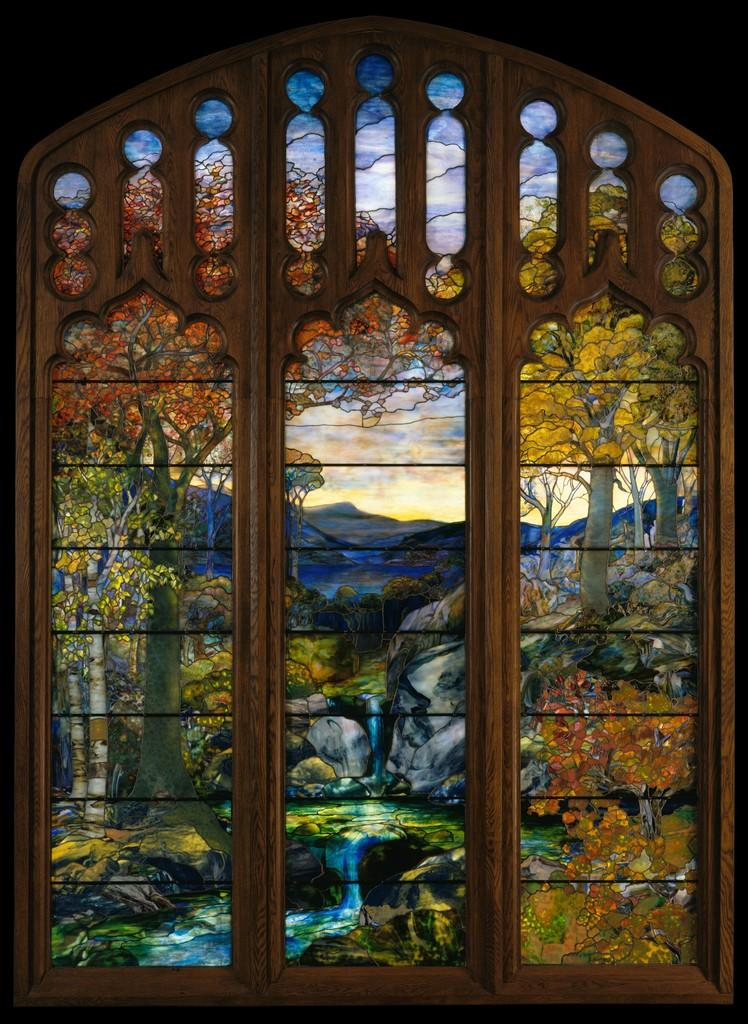What type of opening can be seen in the image? There is a window in the image. What is located near the window? There is a glass visible in the image. What type of natural scenery is visible in the image? Trees are visible in the image. What type of terrain is present in the image? Rocks are present in the image. What is visible above the trees and rocks in the image? The sky is visible in the image. How many bikes are being ridden by the creator in the image? There is no creator or bikes present in the image. What type of worm can be seen crawling on the rocks in the image? There are no worms present in the image; only rocks, trees, a window, a glass, and the sky are visible. 